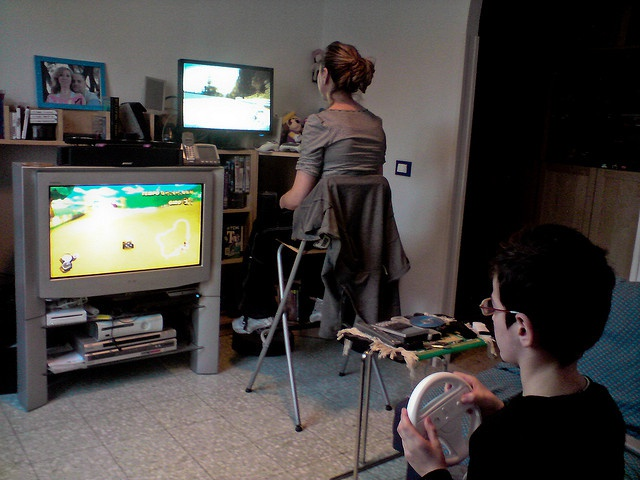Describe the objects in this image and their specific colors. I can see people in gray, black, and maroon tones, tv in gray, ivory, and khaki tones, people in gray and black tones, chair in gray and black tones, and tv in gray, white, black, and purple tones in this image. 